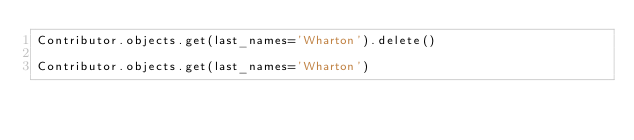Convert code to text. <code><loc_0><loc_0><loc_500><loc_500><_Python_>Contributor.objects.get(last_names='Wharton').delete()

Contributor.objects.get(last_names='Wharton')
</code> 